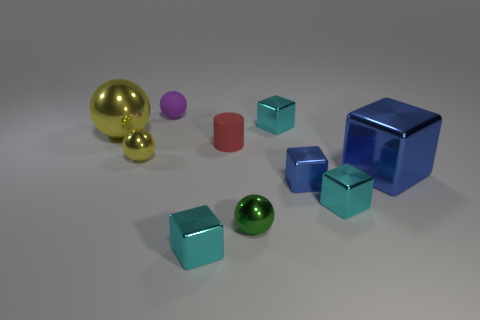Subtract all cyan blocks. How many blocks are left? 2 Subtract all cylinders. How many objects are left? 9 Subtract 1 blocks. How many blocks are left? 4 Subtract all blue blocks. How many blocks are left? 3 Subtract all brown balls. How many cyan cylinders are left? 0 Subtract all yellow balls. Subtract all large balls. How many objects are left? 7 Add 7 tiny cylinders. How many tiny cylinders are left? 8 Add 3 red rubber cylinders. How many red rubber cylinders exist? 4 Subtract 1 cyan cubes. How many objects are left? 9 Subtract all blue blocks. Subtract all cyan cylinders. How many blocks are left? 3 